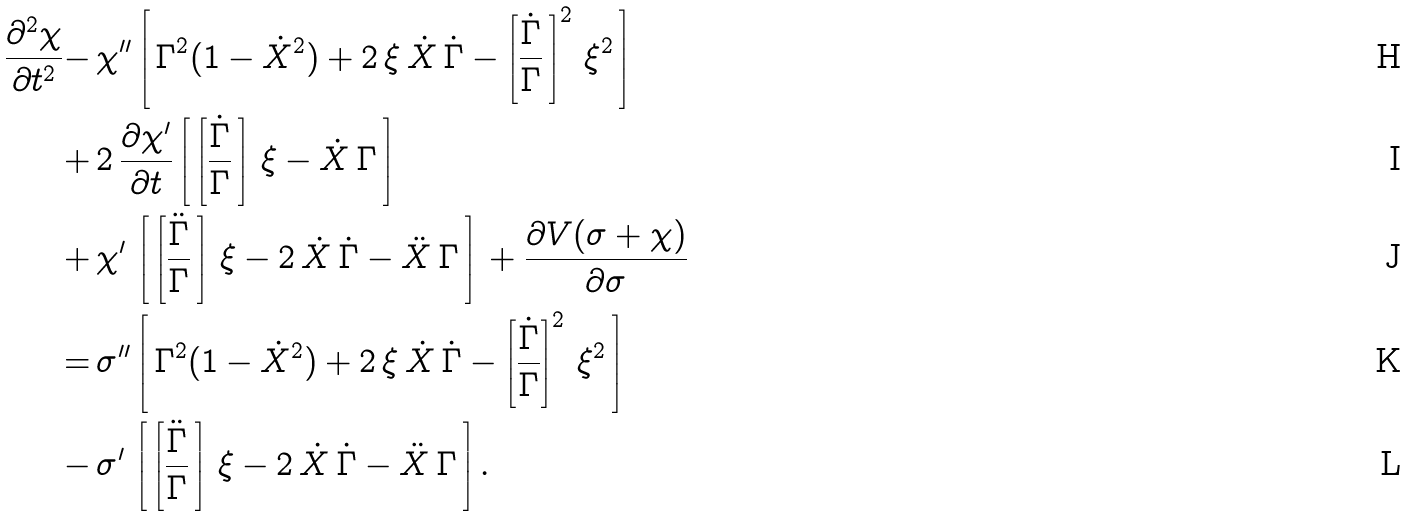<formula> <loc_0><loc_0><loc_500><loc_500>\frac { \partial ^ { 2 } \chi } { \partial t ^ { 2 } } - \, & \chi ^ { \prime \prime } \left [ \, \Gamma ^ { 2 } ( 1 - \dot { X } ^ { 2 } ) + 2 \, \xi \, \dot { X } \, \dot { \Gamma } - \left [ \frac { \dot { \Gamma } } { \Gamma } \, \right ] ^ { 2 } \, \xi ^ { 2 } \, \right ] \\ + \, & 2 \, \frac { \partial \chi ^ { \prime } } { \partial t } \left [ \, \left [ \frac { \dot { \Gamma } } { \Gamma } \, \right ] \, \xi - \dot { X } \, \Gamma \, \right ] \\ + \, & \chi ^ { \prime } \, \left [ \, \left [ \frac { \ddot { \Gamma } } { \Gamma } \, \right ] \, \xi - 2 \, \dot { X } \, \dot { \Gamma } - \ddot { X } \, \Gamma \, \right ] \, + \frac { \partial V ( \sigma + \chi ) } { \partial \sigma } \\ = \, & \sigma ^ { \prime \prime } \left [ \, \Gamma ^ { 2 } ( 1 - \dot { X } ^ { 2 } ) + 2 \, \xi \, \dot { X } \, \dot { \Gamma } - \left [ \frac { \dot { \Gamma } } { \Gamma } \right ] ^ { 2 } \, \xi ^ { 2 } \, \right ] \\ - \, & \sigma ^ { \prime } \, \left [ \, \left [ \frac { \ddot { \Gamma } } { \Gamma } \, \right ] \, \xi - 2 \, \dot { X } \, \dot { \Gamma } - \ddot { X } \, \Gamma \, \right ] .</formula> 